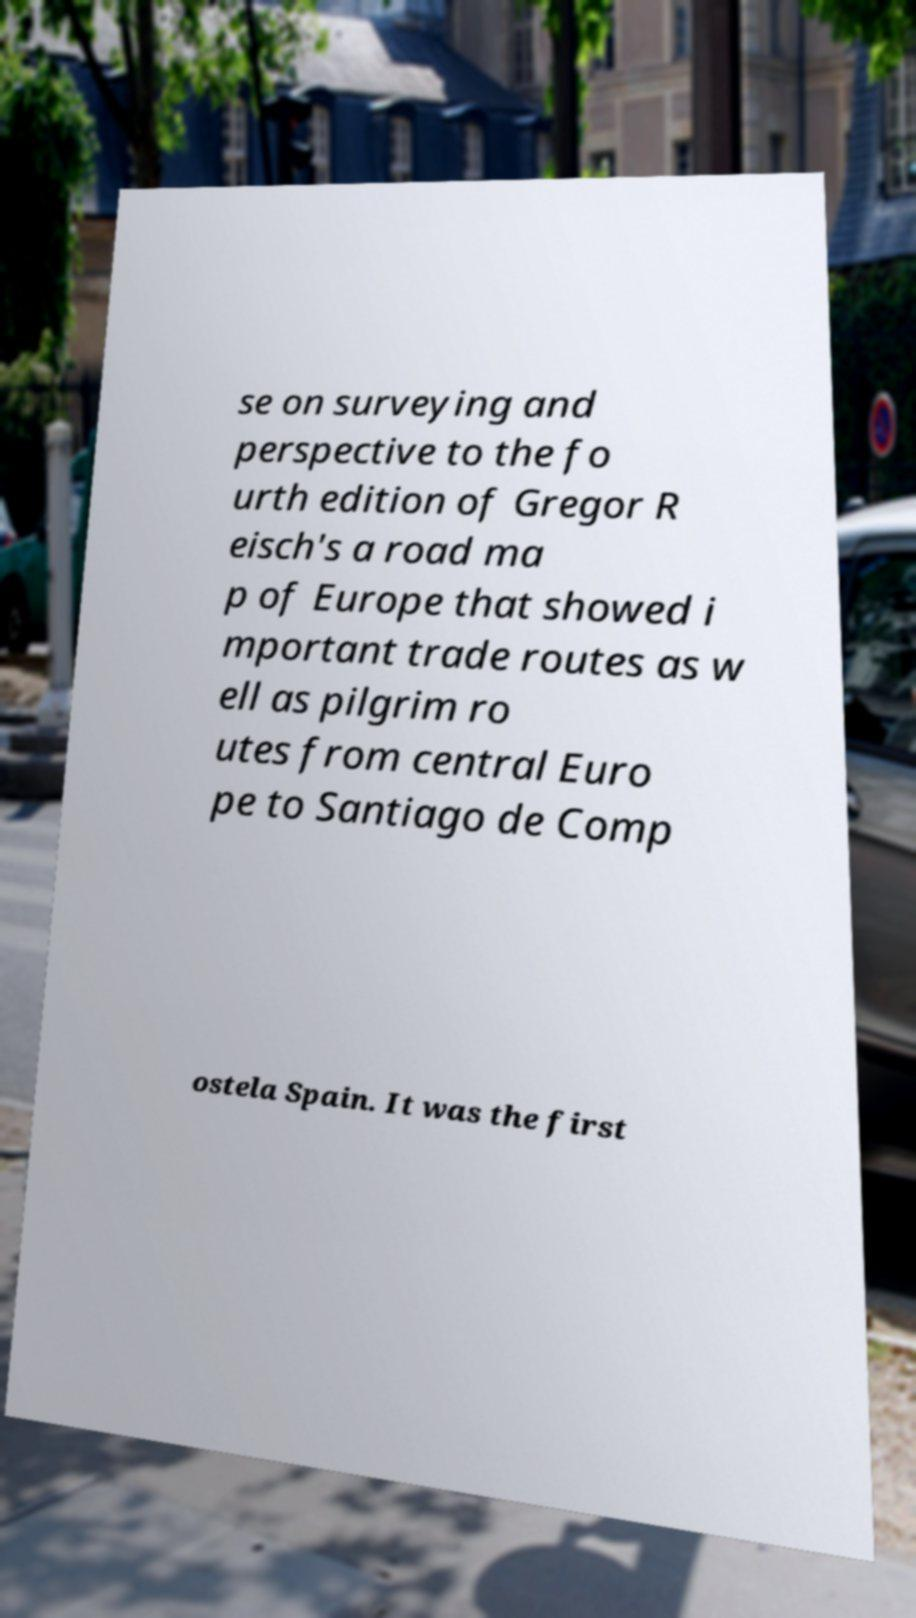Please read and relay the text visible in this image. What does it say? se on surveying and perspective to the fo urth edition of Gregor R eisch's a road ma p of Europe that showed i mportant trade routes as w ell as pilgrim ro utes from central Euro pe to Santiago de Comp ostela Spain. It was the first 